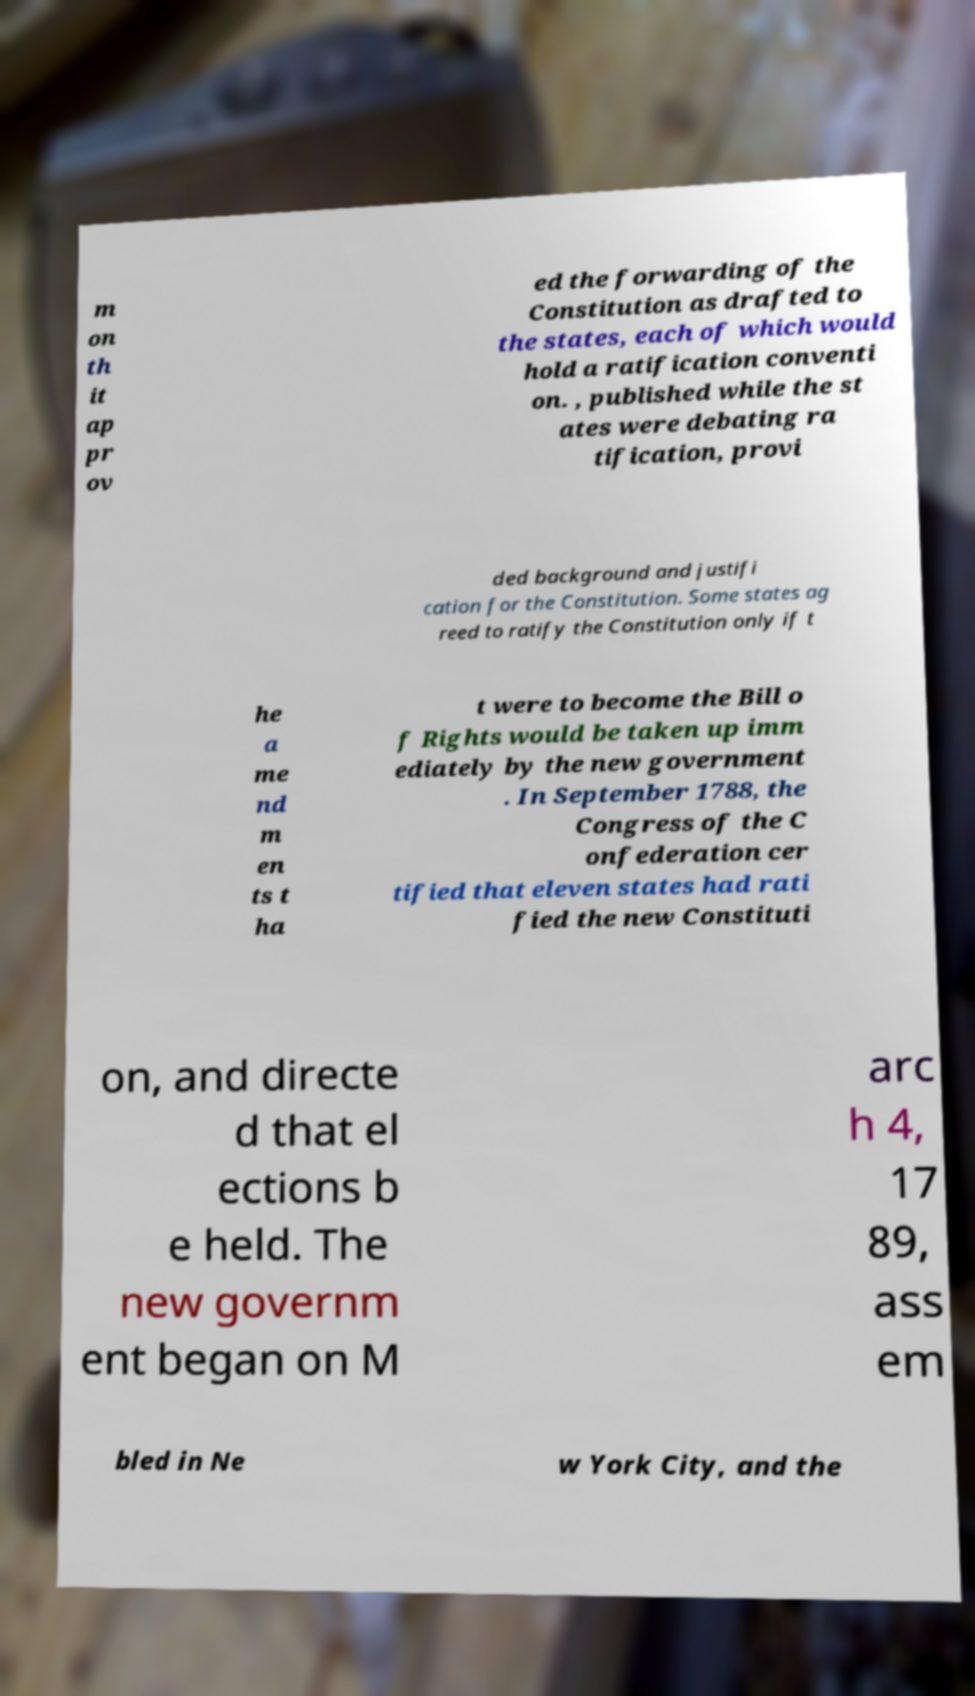I need the written content from this picture converted into text. Can you do that? m on th it ap pr ov ed the forwarding of the Constitution as drafted to the states, each of which would hold a ratification conventi on. , published while the st ates were debating ra tification, provi ded background and justifi cation for the Constitution. Some states ag reed to ratify the Constitution only if t he a me nd m en ts t ha t were to become the Bill o f Rights would be taken up imm ediately by the new government . In September 1788, the Congress of the C onfederation cer tified that eleven states had rati fied the new Constituti on, and directe d that el ections b e held. The new governm ent began on M arc h 4, 17 89, ass em bled in Ne w York City, and the 